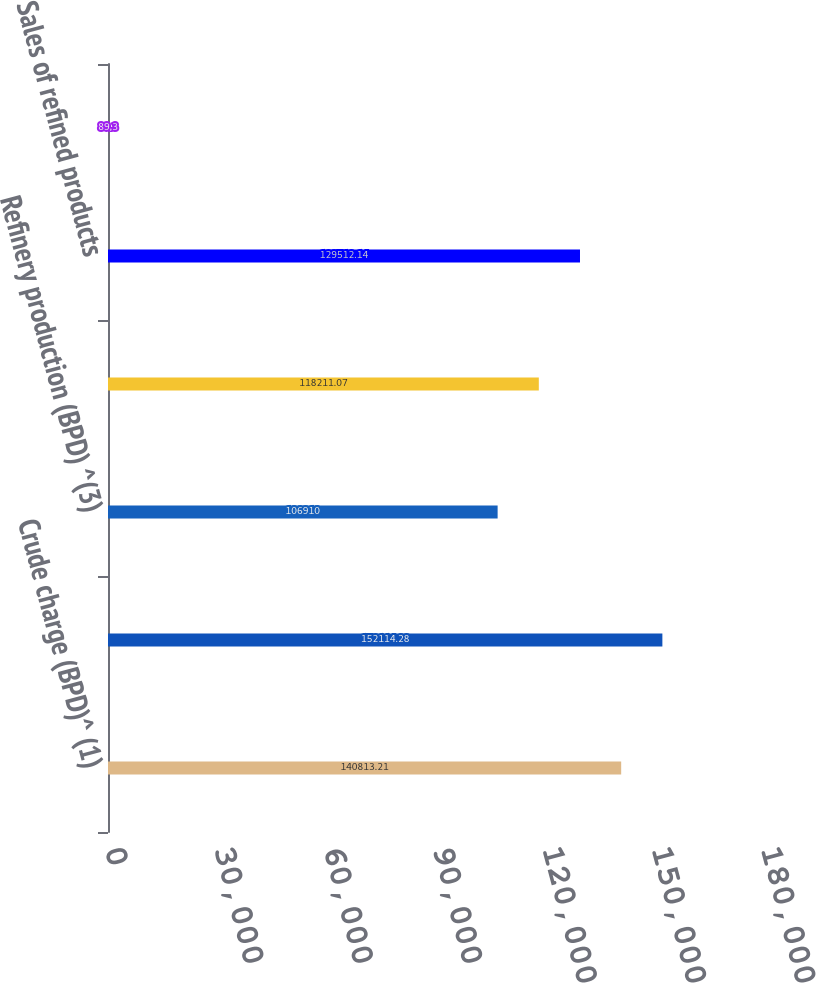Convert chart to OTSL. <chart><loc_0><loc_0><loc_500><loc_500><bar_chart><fcel>Crude charge (BPD)^ (1)<fcel>Refinery throughput (BPD) ^(2)<fcel>Refinery production (BPD) ^(3)<fcel>Sales of produced refined<fcel>Sales of refined products<fcel>Refinery utilization ^(5)<nl><fcel>140813<fcel>152114<fcel>106910<fcel>118211<fcel>129512<fcel>89.3<nl></chart> 